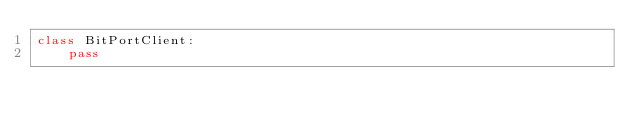<code> <loc_0><loc_0><loc_500><loc_500><_Python_>class BitPortClient:
    pass
</code> 